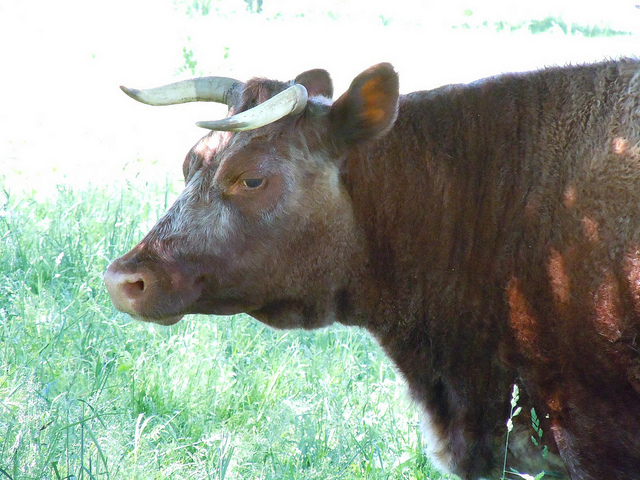What kind of bull is this?
Answer the question using a single word or phrase. Longhorn 